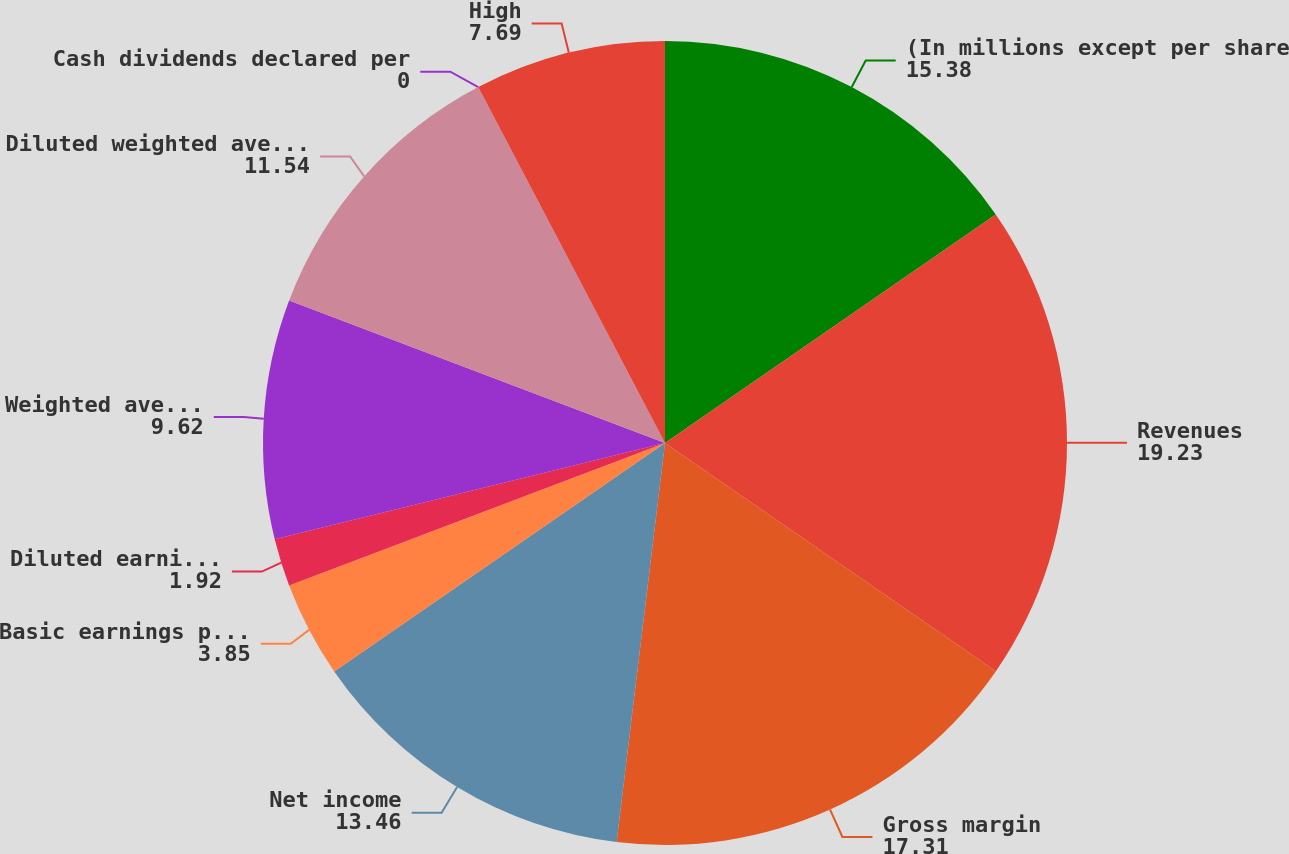Convert chart. <chart><loc_0><loc_0><loc_500><loc_500><pie_chart><fcel>(In millions except per share<fcel>Revenues<fcel>Gross margin<fcel>Net income<fcel>Basic earnings per common<fcel>Diluted earnings per common<fcel>Weighted average common shares<fcel>Diluted weighted average<fcel>Cash dividends declared per<fcel>High<nl><fcel>15.38%<fcel>19.23%<fcel>17.31%<fcel>13.46%<fcel>3.85%<fcel>1.92%<fcel>9.62%<fcel>11.54%<fcel>0.0%<fcel>7.69%<nl></chart> 